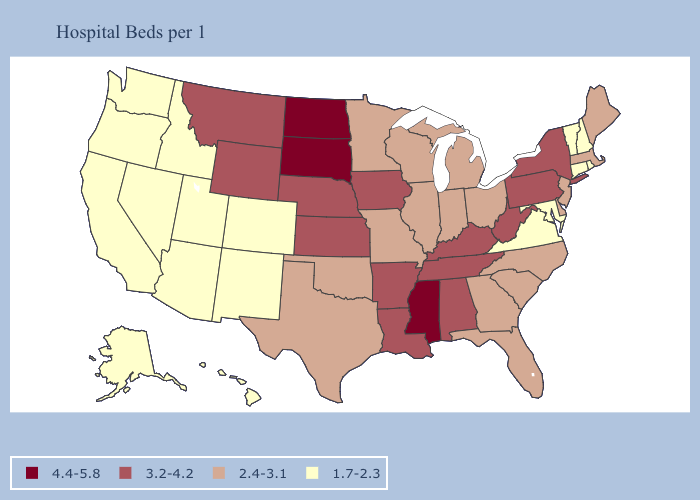Among the states that border Texas , does Louisiana have the lowest value?
Concise answer only. No. Among the states that border Texas , does Oklahoma have the highest value?
Keep it brief. No. What is the value of North Dakota?
Concise answer only. 4.4-5.8. Is the legend a continuous bar?
Write a very short answer. No. What is the value of Ohio?
Concise answer only. 2.4-3.1. What is the value of Oklahoma?
Keep it brief. 2.4-3.1. How many symbols are there in the legend?
Answer briefly. 4. Which states have the lowest value in the Northeast?
Keep it brief. Connecticut, New Hampshire, Rhode Island, Vermont. What is the value of Nebraska?
Answer briefly. 3.2-4.2. Does New Jersey have the same value as Illinois?
Be succinct. Yes. What is the highest value in states that border Wyoming?
Quick response, please. 4.4-5.8. Name the states that have a value in the range 4.4-5.8?
Keep it brief. Mississippi, North Dakota, South Dakota. Which states have the highest value in the USA?
Short answer required. Mississippi, North Dakota, South Dakota. Does the map have missing data?
Quick response, please. No. How many symbols are there in the legend?
Write a very short answer. 4. 